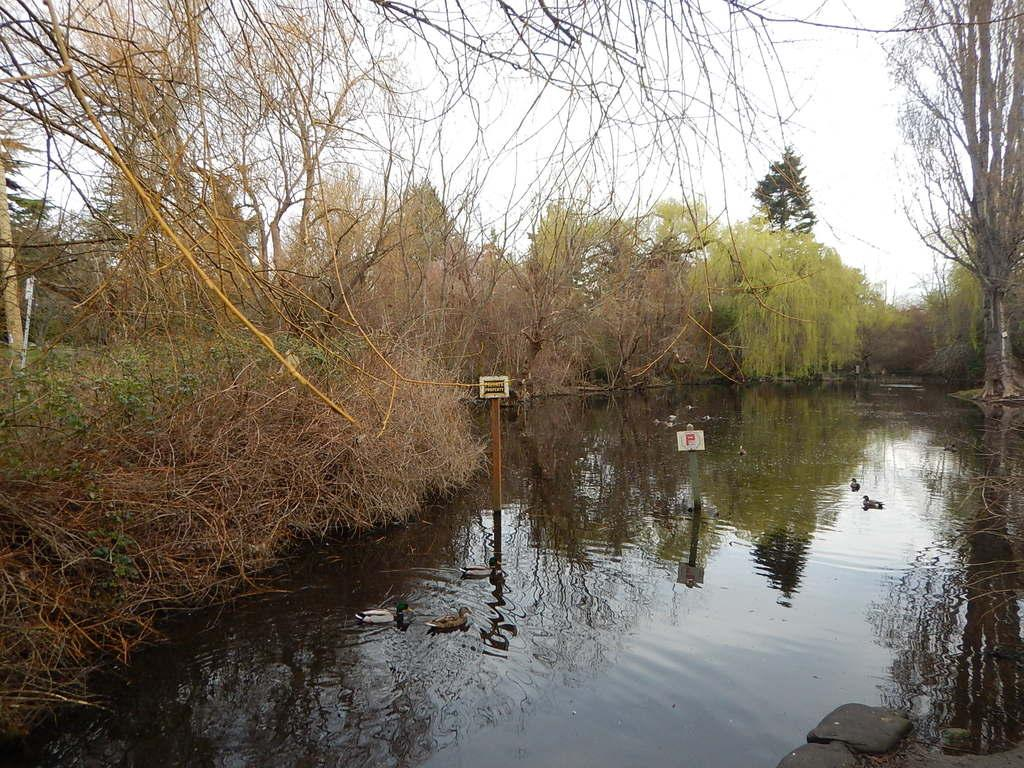What is present in the image that is related to water? There is water in the image. What type of animals can be seen in the image? There are birds in the image. What structures are visible in the image? There are poles and boards in the image. What type of vegetation is present in the image? There are plants and trees in the image. What part of the natural environment is visible in the background of the image? The sky is visible in the background of the image. What is the size of the basin in the image? There is no basin present in the image. How many seeds can be seen in the image? There are no seeds visible in the image. 